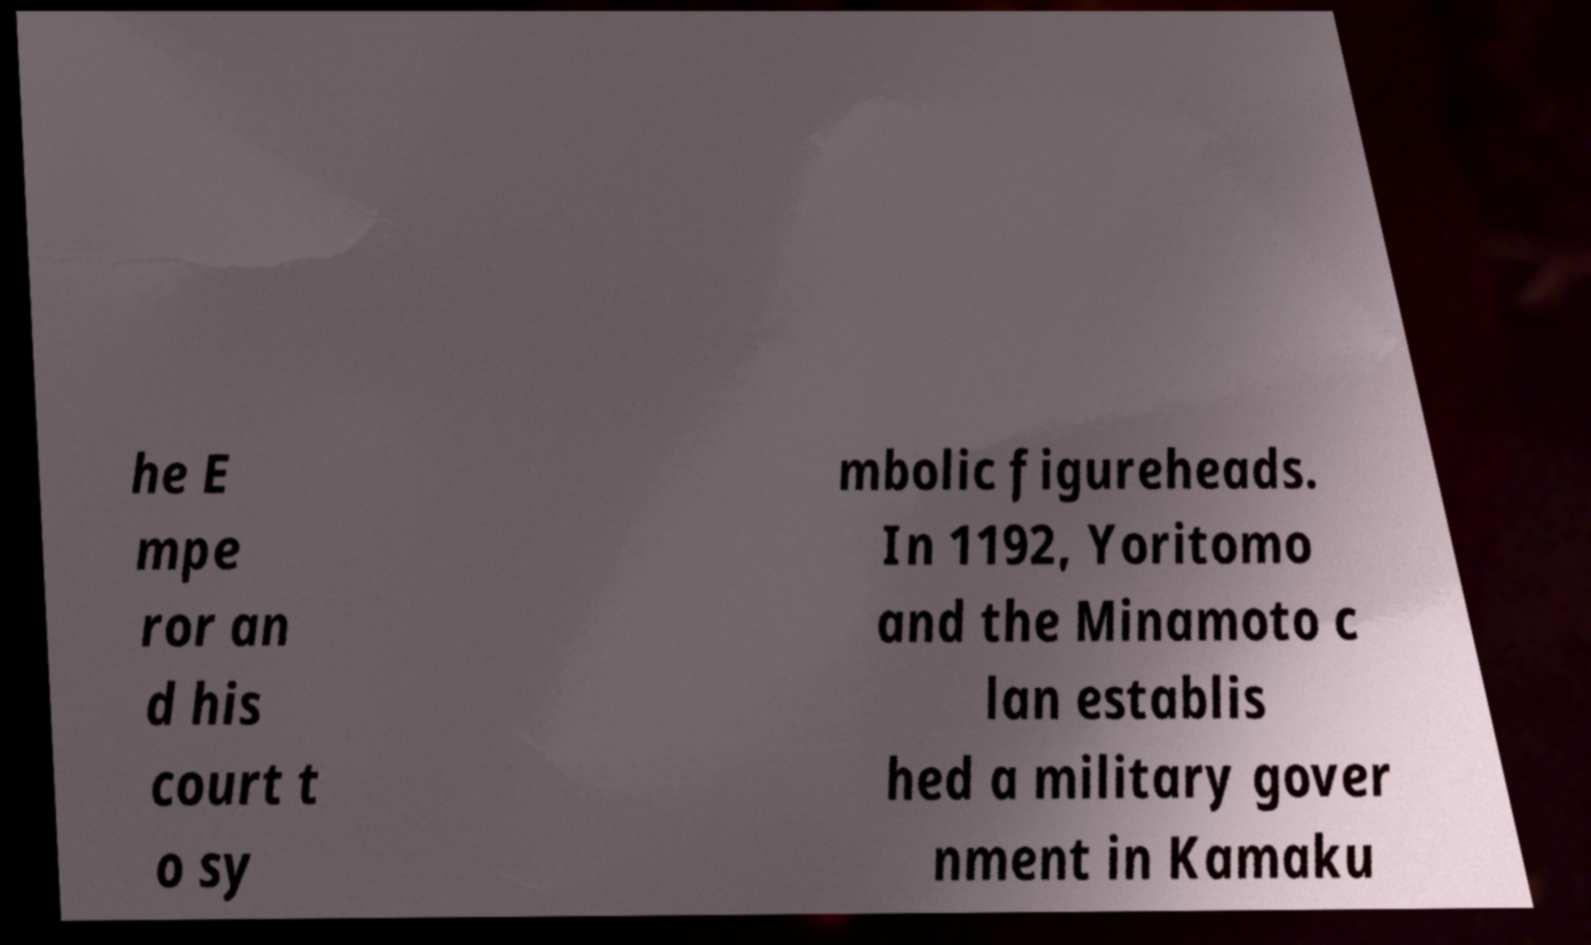Can you read and provide the text displayed in the image?This photo seems to have some interesting text. Can you extract and type it out for me? he E mpe ror an d his court t o sy mbolic figureheads. In 1192, Yoritomo and the Minamoto c lan establis hed a military gover nment in Kamaku 